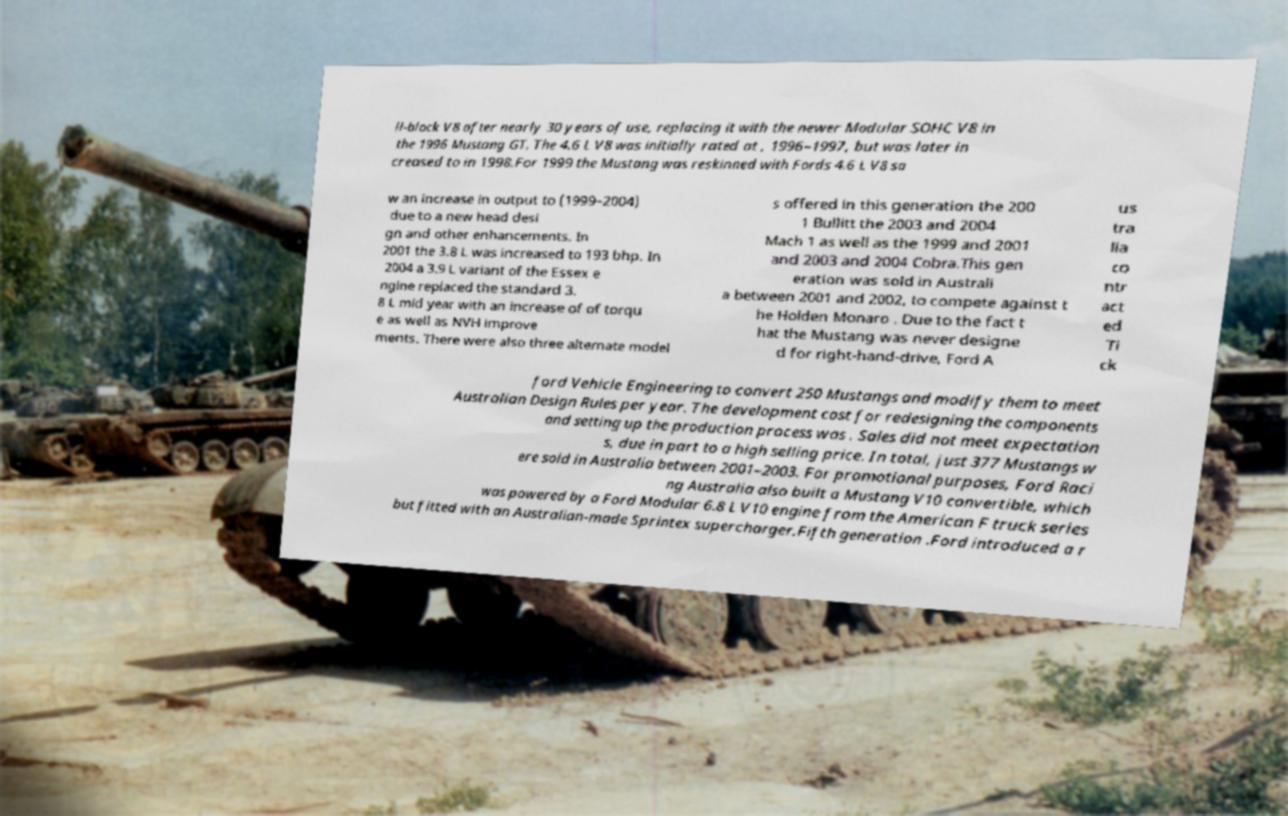Could you extract and type out the text from this image? ll-block V8 after nearly 30 years of use, replacing it with the newer Modular SOHC V8 in the 1996 Mustang GT. The 4.6 L V8 was initially rated at , 1996–1997, but was later in creased to in 1998.For 1999 the Mustang was reskinned with Fords 4.6 L V8 sa w an increase in output to (1999–2004) due to a new head desi gn and other enhancements. In 2001 the 3.8 L was increased to 193 bhp. In 2004 a 3.9 L variant of the Essex e ngine replaced the standard 3. 8 L mid year with an increase of of torqu e as well as NVH improve ments. There were also three alternate model s offered in this generation the 200 1 Bullitt the 2003 and 2004 Mach 1 as well as the 1999 and 2001 and 2003 and 2004 Cobra.This gen eration was sold in Australi a between 2001 and 2002, to compete against t he Holden Monaro . Due to the fact t hat the Mustang was never designe d for right-hand-drive, Ford A us tra lia co ntr act ed Ti ck ford Vehicle Engineering to convert 250 Mustangs and modify them to meet Australian Design Rules per year. The development cost for redesigning the components and setting up the production process was . Sales did not meet expectation s, due in part to a high selling price. In total, just 377 Mustangs w ere sold in Australia between 2001–2003. For promotional purposes, Ford Raci ng Australia also built a Mustang V10 convertible, which was powered by a Ford Modular 6.8 L V10 engine from the American F truck series but fitted with an Australian-made Sprintex supercharger.Fifth generation .Ford introduced a r 